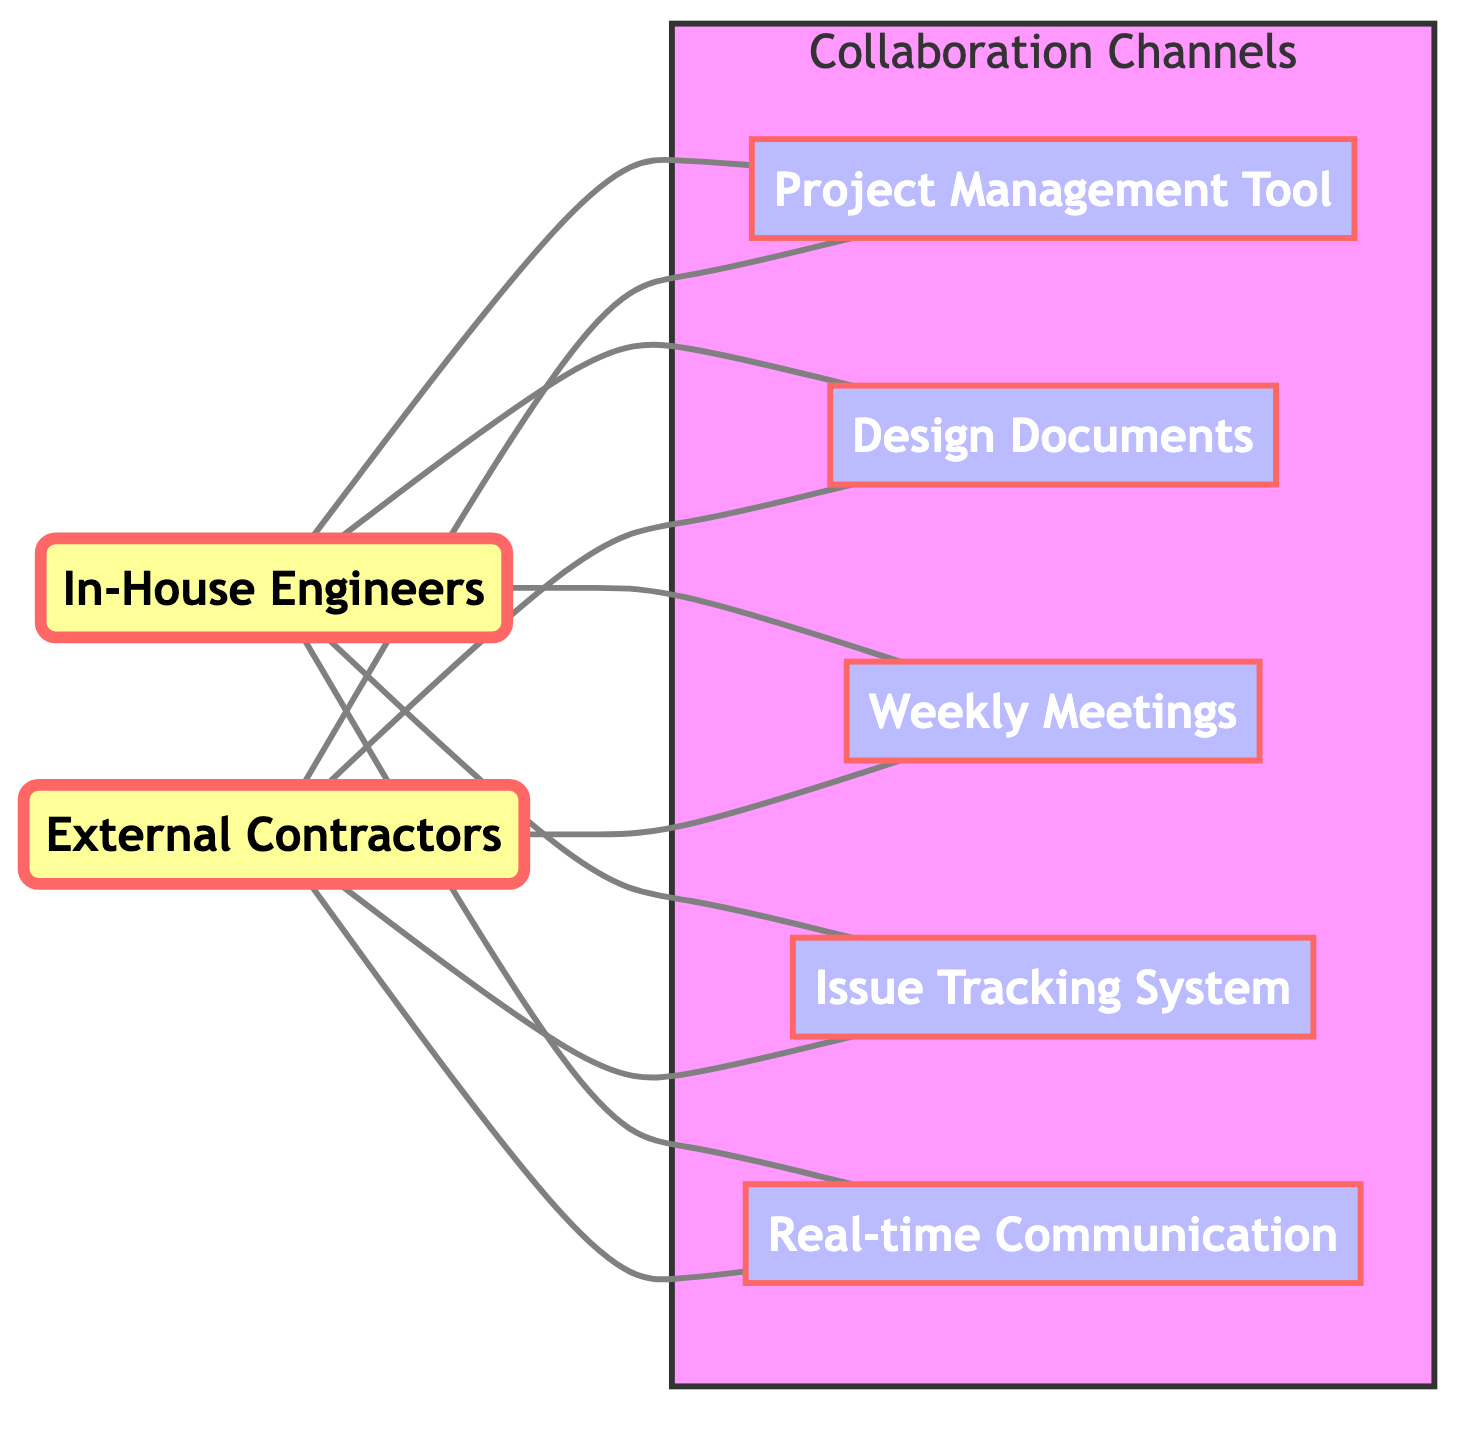What are the two main groups represented in the diagram? The diagram includes two main groups: "In-House Engineers" and "External Contractors", which are identified as the primary actors in the collaboration.
Answer: In-House Engineers, External Contractors How many collaboration channels are depicted in total? The diagram shows a total of five collaboration channels: Project Management Tool, Design Documents, Weekly Meetings, Issue Tracking System, and Real-time Communication.
Answer: 5 What action do In-House Engineers perform in relation to Design Documents? The diagram indicates that In-House Engineers "create" Design Documents, which reflects their role in generating the necessary design specifications for projects.
Answer: creates Which channel is used for tracking issues? The diagram includes the "Issue Tracking System" as the specified channel used for reporting and updating issues within the collaboration framework.
Answer: Issue Tracking System How do External Contractors interact with Real-time Communication? According to the diagram, External Contractors "interact via" Real-time Communication channels such as Slack or Microsoft Teams, highlighting their communication practices.
Answer: interacts via How many types of meetings do In-House Engineers participate in? In-House Engineers participate in one type of meeting, which is the Weekly Meetings, as indicated by the connection in the diagram.
Answer: 1 What type of access do External Contractors have to the Project Management Tool? The diagram shows that External Contractors "access" the Project Management Tool, indicating their ability to view or manage project information.
Answer: accesses What is the relationship between In-House Engineers and the Issue Tracking System? In-House Engineers "report issues" in relation to the Issue Tracking System, demonstrating their responsibility in communicating problems that arise.
Answer: reports issues How many nodes related to external collaboration are present in the diagram? The external collaboration nodes represented in the diagram include the External Contractors, Project Management Tool, Design Documents, Weekly Meetings, Issue Tracking System, and Real-time Communication; totaling six nodes.
Answer: 6 